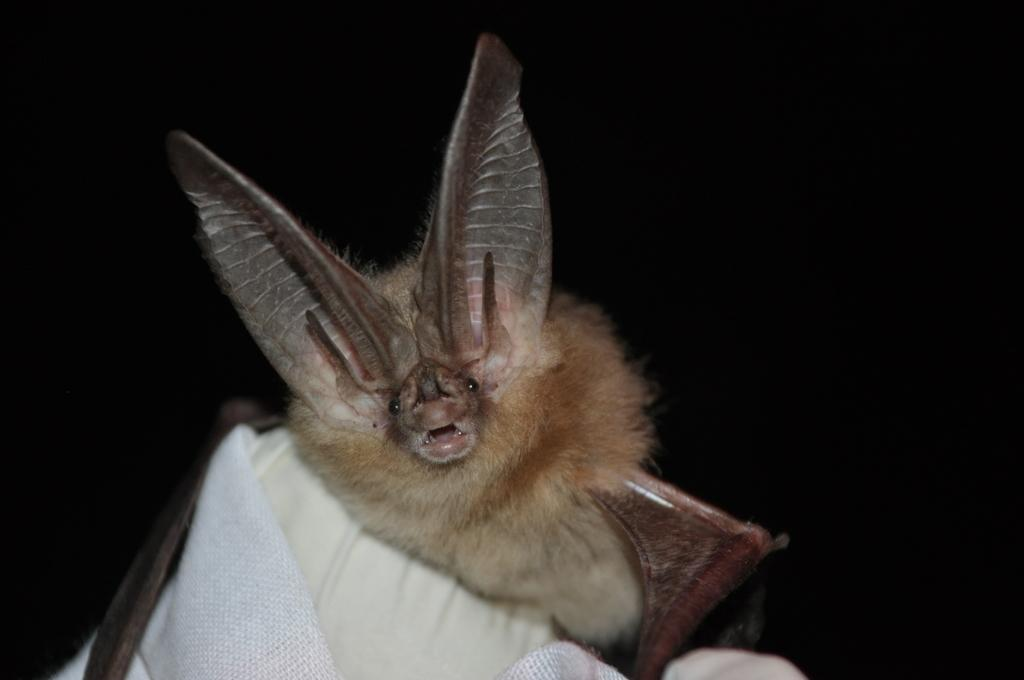What type of creature is present in the image? There is an animal in the image. Where is the animal located? The animal is on a pillow. What type of plants can be seen growing on the animal in the image? There are no plants visible on the animal in the image. 